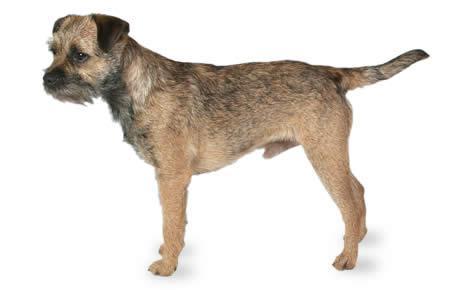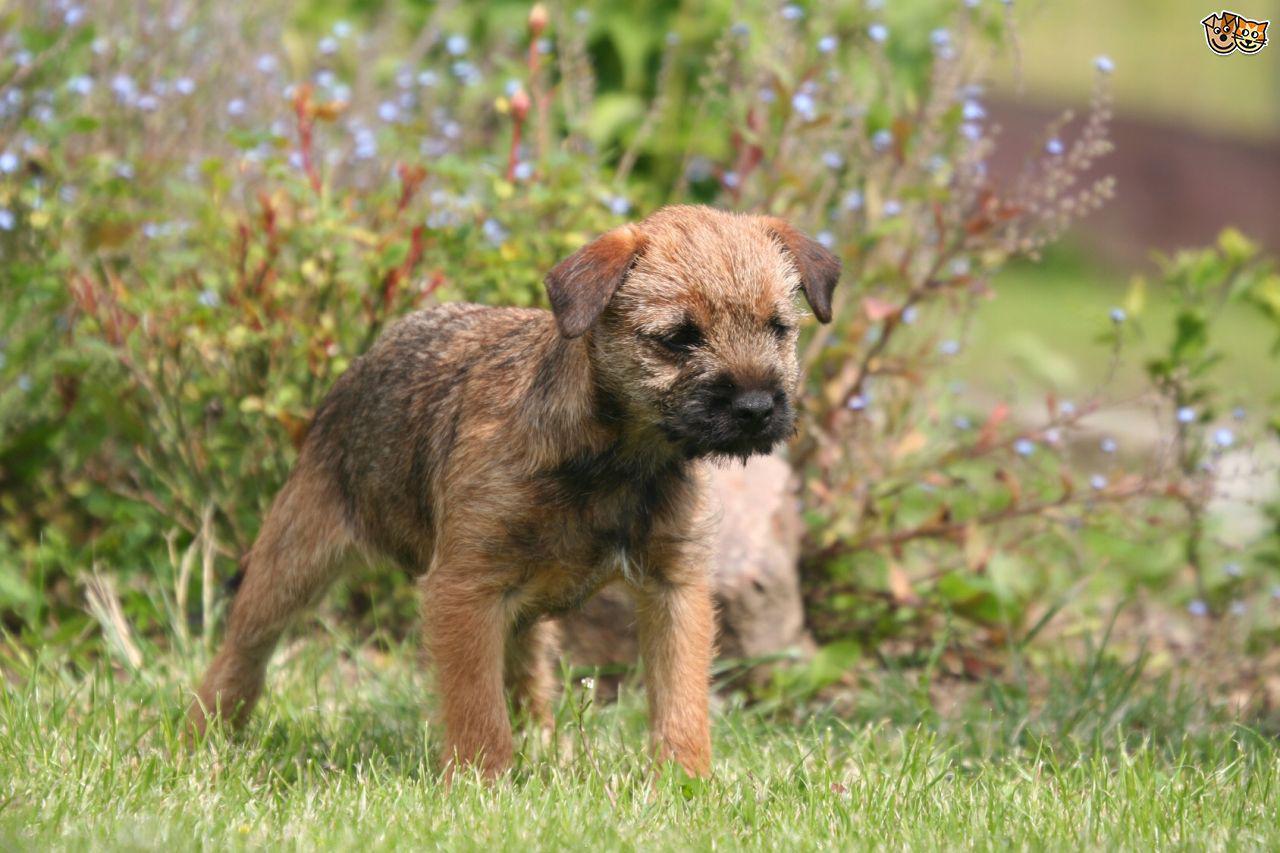The first image is the image on the left, the second image is the image on the right. Considering the images on both sides, is "The left image contains a dog facing towards the left." valid? Answer yes or no. Yes. The first image is the image on the left, the second image is the image on the right. Evaluate the accuracy of this statement regarding the images: "A dog stands still in profile facing left with tail extended out.". Is it true? Answer yes or no. Yes. 